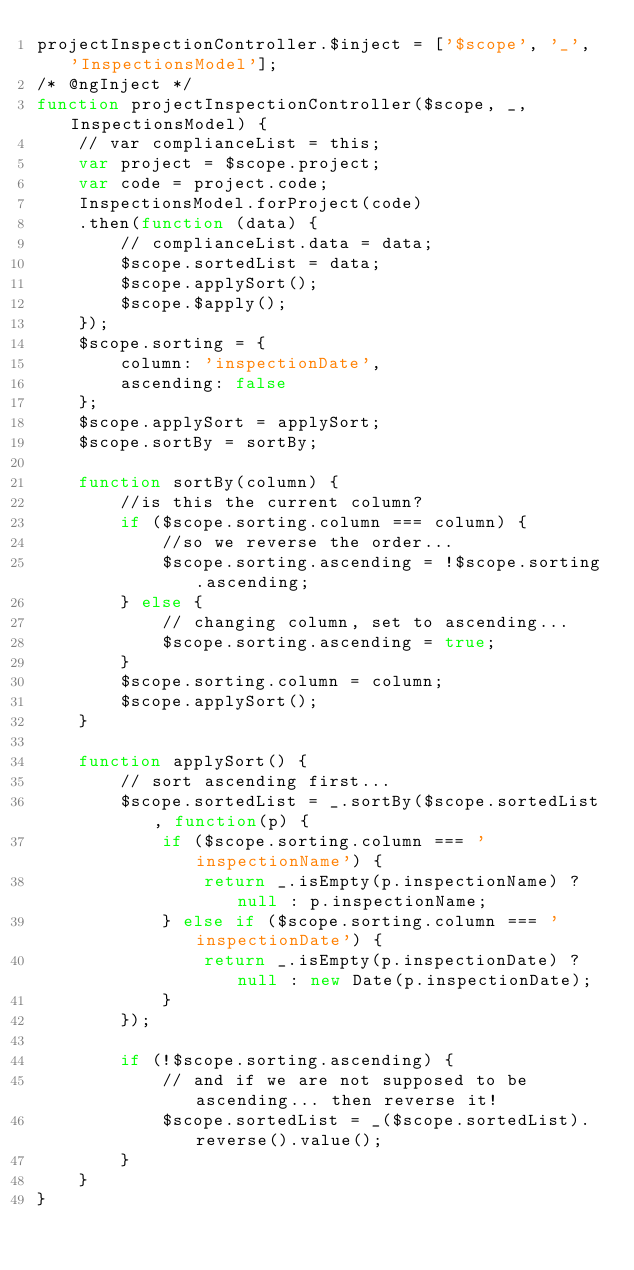<code> <loc_0><loc_0><loc_500><loc_500><_JavaScript_>projectInspectionController.$inject = ['$scope', '_', 'InspectionsModel'];
/* @ngInject */
function projectInspectionController($scope, _, InspectionsModel) {
	// var complianceList = this;
	var project = $scope.project;
	var code = project.code;
	InspectionsModel.forProject(code)
	.then(function (data) {
		// complianceList.data = data;
		$scope.sortedList = data;
		$scope.applySort();
		$scope.$apply();
	});
	$scope.sorting = {
		column: 'inspectionDate',
		ascending: false
	};
	$scope.applySort = applySort;
	$scope.sortBy = sortBy;

	function sortBy(column) {
		//is this the current column?
		if ($scope.sorting.column === column) {
			//so we reverse the order...
			$scope.sorting.ascending = !$scope.sorting.ascending;
		} else {
			// changing column, set to ascending...
			$scope.sorting.ascending = true;
		}
		$scope.sorting.column = column;
		$scope.applySort();
	}

	function applySort() {
		// sort ascending first...
		$scope.sortedList = _.sortBy($scope.sortedList, function(p) {
			if ($scope.sorting.column === 'inspectionName') {
				return _.isEmpty(p.inspectionName) ? null : p.inspectionName;
			} else if ($scope.sorting.column === 'inspectionDate') {
				return _.isEmpty(p.inspectionDate) ? null : new Date(p.inspectionDate);
			}
		});

		if (!$scope.sorting.ascending) {
			// and if we are not supposed to be ascending... then reverse it!
			$scope.sortedList = _($scope.sortedList).reverse().value();
		}
	}
}
</code> 